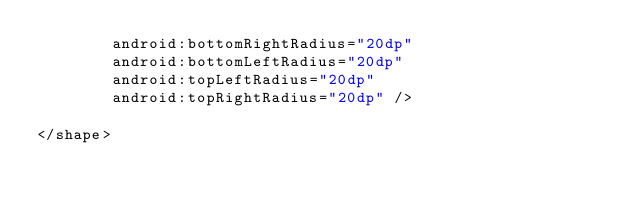Convert code to text. <code><loc_0><loc_0><loc_500><loc_500><_XML_>        android:bottomRightRadius="20dp"
        android:bottomLeftRadius="20dp"
        android:topLeftRadius="20dp"
        android:topRightRadius="20dp" />

</shape></code> 